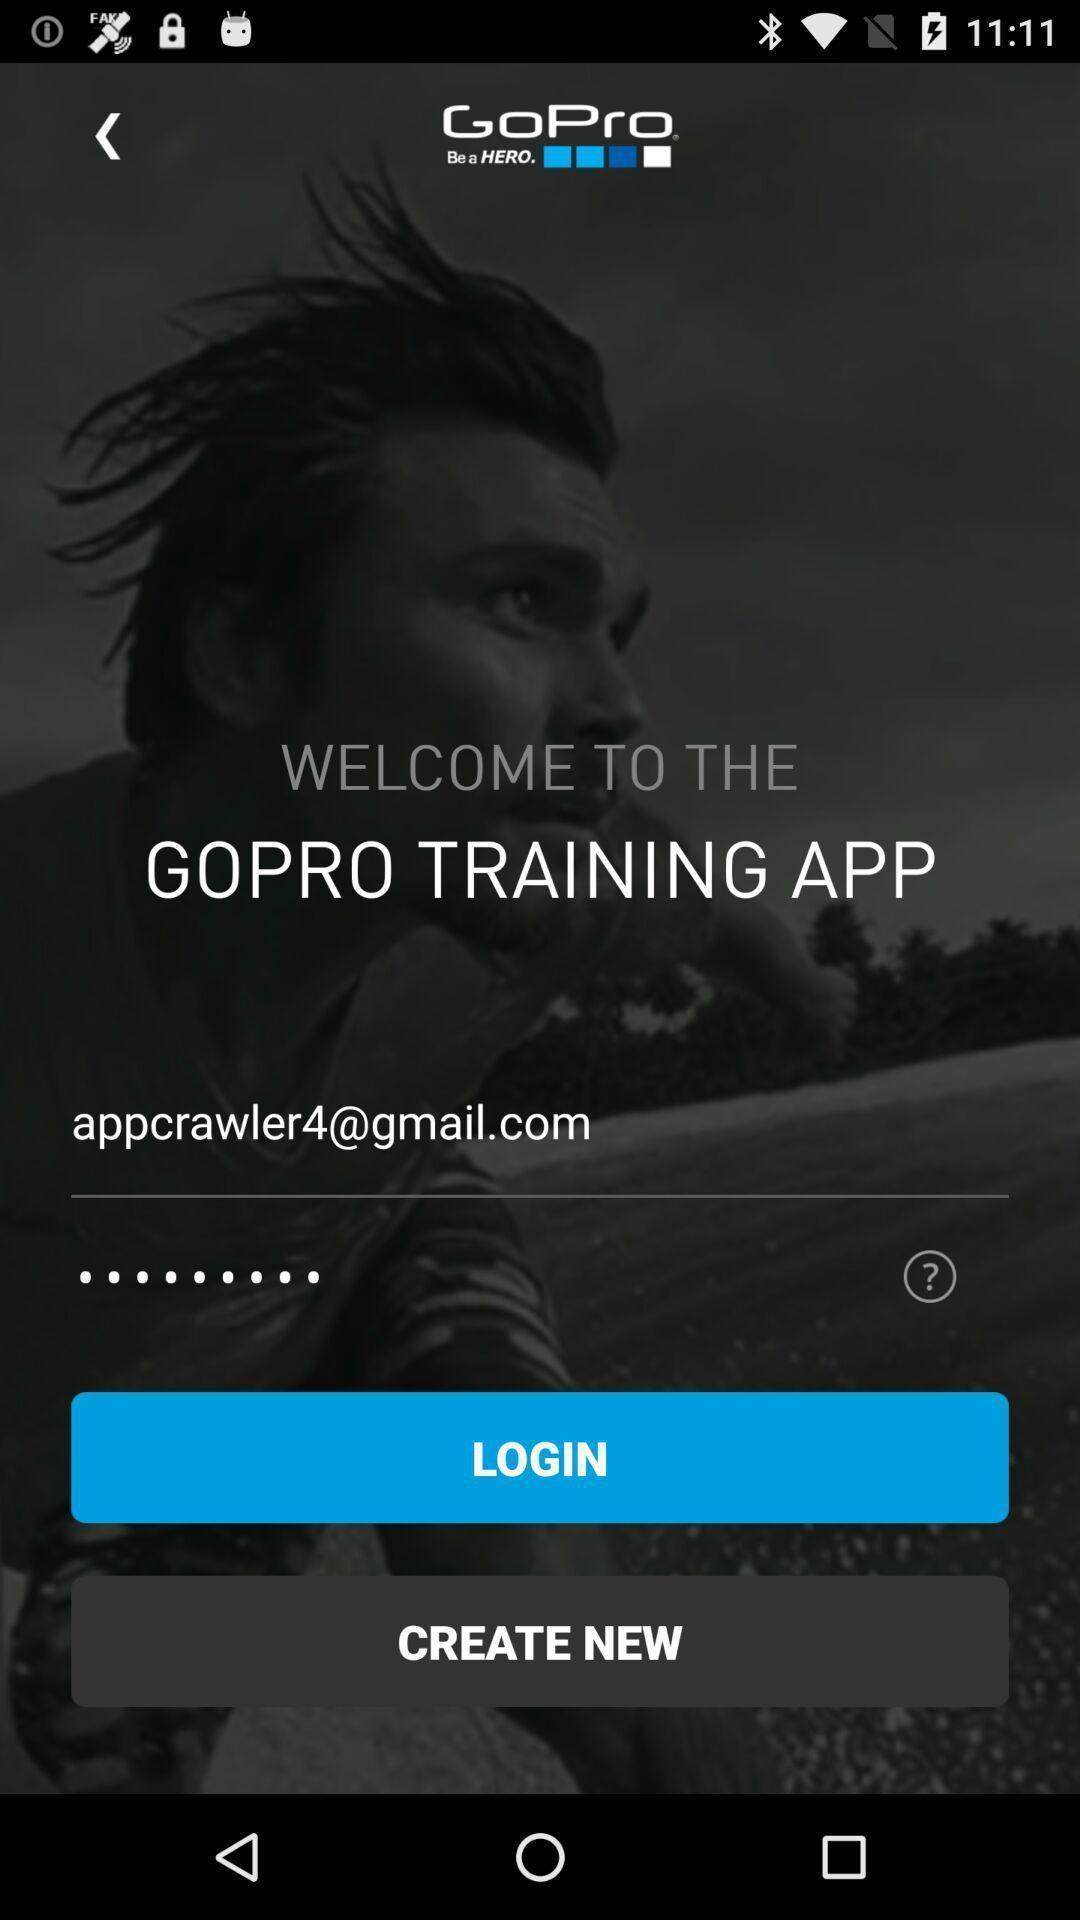Tell me what you see in this picture. Sign in page. 